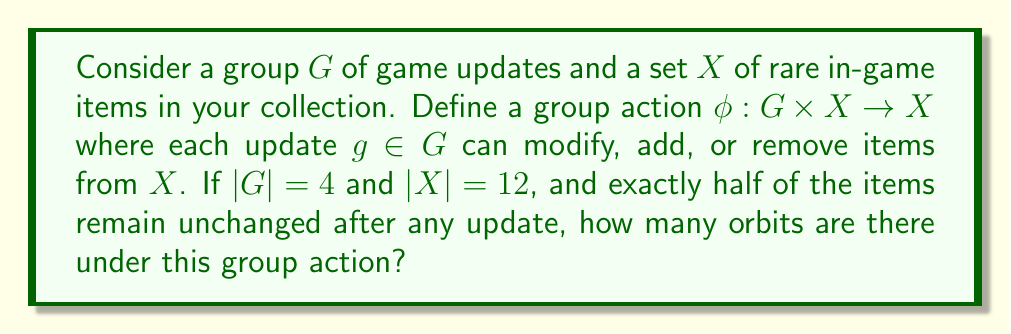Can you answer this question? Let's approach this step-by-step using Burnside's lemma:

1) Burnside's lemma states that the number of orbits is equal to the average number of elements fixed by each group element:

   $$|X/G| = \frac{1}{|G|} \sum_{g \in G} |X^g|$$

   where $X^g$ is the set of elements in $X$ fixed by $g$.

2) We're given that $|G| = 4$ and $|X| = 12$.

3) We're also told that exactly half of the items remain unchanged after any update. This means that for each $g \in G$, $|X^g| = 6$ (half of 12).

4) Applying Burnside's lemma:

   $$|X/G| = \frac{1}{4} (6 + 6 + 6 + 6) = \frac{24}{4} = 6$$

5) Therefore, there are 6 orbits under this group action.

This result means that the rare items in the collection can be categorized into 6 distinct groups based on how they are affected by the game updates.
Answer: 6 orbits 